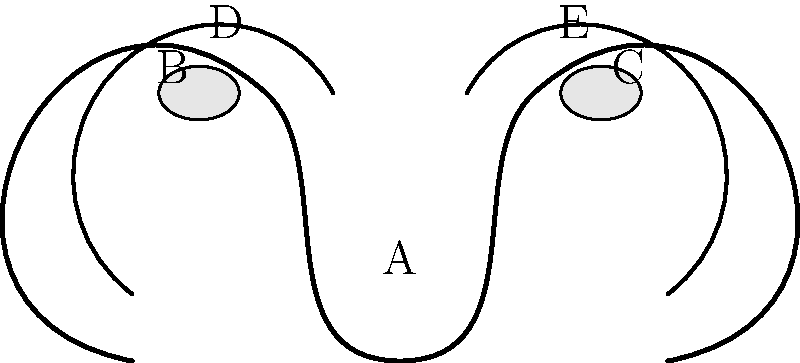Identify the structures labeled A through E in this diagram of the female reproductive system. Which of these structures is responsible for producing eggs (ova)? To answer this question, let's break down each labeled structure:

1. Structure A: This is the uterus, also known as the womb. It's where a fertilized egg implants and develops during pregnancy.

2. Structure B and C: These are the ovaries. They are almond-shaped glands that produce and release eggs (ova) during ovulation. They also produce hormones like estrogen and progesterone.

3. Structure D and E: These are the fallopian tubes (also called oviducts). They connect the ovaries to the uterus and serve as the site for fertilization.

The structure responsible for producing eggs (ova) is the ovary. In this diagram, there are two ovaries labeled as B and C.

The process of egg production, called oogenesis, occurs within the ovaries. Primordial germ cells in the ovary develop into oogonia, which then become primary oocytes. These primary oocytes are present in the ovaries at birth and remain dormant until puberty. During each menstrual cycle, usually one primary oocyte matures into a secondary oocyte and is released from the ovary during ovulation.

Therefore, the correct answer is that structures B and C (the ovaries) are responsible for producing eggs (ova).
Answer: B and C (ovaries) 